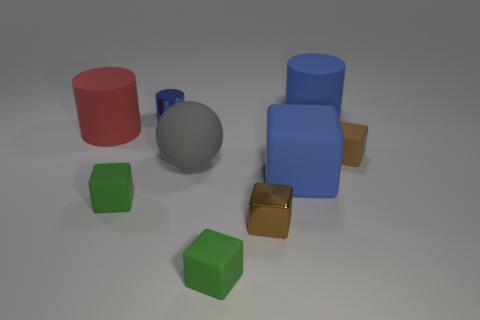What material is the red cylinder made from? This red cylinder appears to be made of plastic, common for such objects to ensure vibrant color and lightweight properties. How would the object's usage differ if it were made of metal instead of plastic? If the red cylinder were made of metal, it would likely be heavier and more durable, possibly intended for more practical, long-lasting applications rather than just as a toy or decorative item. 